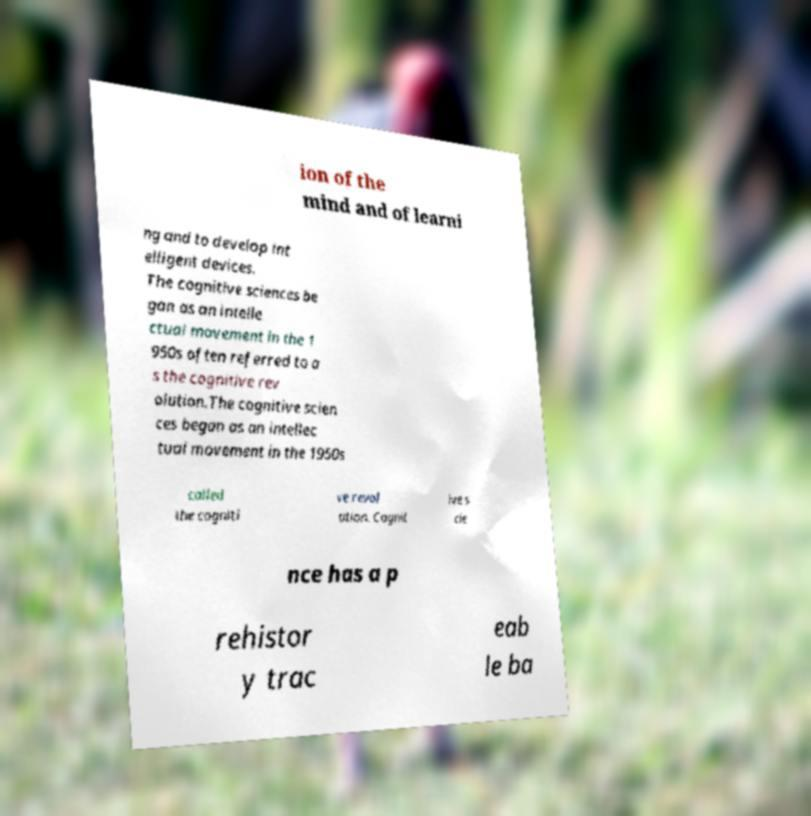Could you assist in decoding the text presented in this image and type it out clearly? ion of the mind and of learni ng and to develop int elligent devices. The cognitive sciences be gan as an intelle ctual movement in the 1 950s often referred to a s the cognitive rev olution.The cognitive scien ces began as an intellec tual movement in the 1950s called the cogniti ve revol ution. Cognit ive s cie nce has a p rehistor y trac eab le ba 